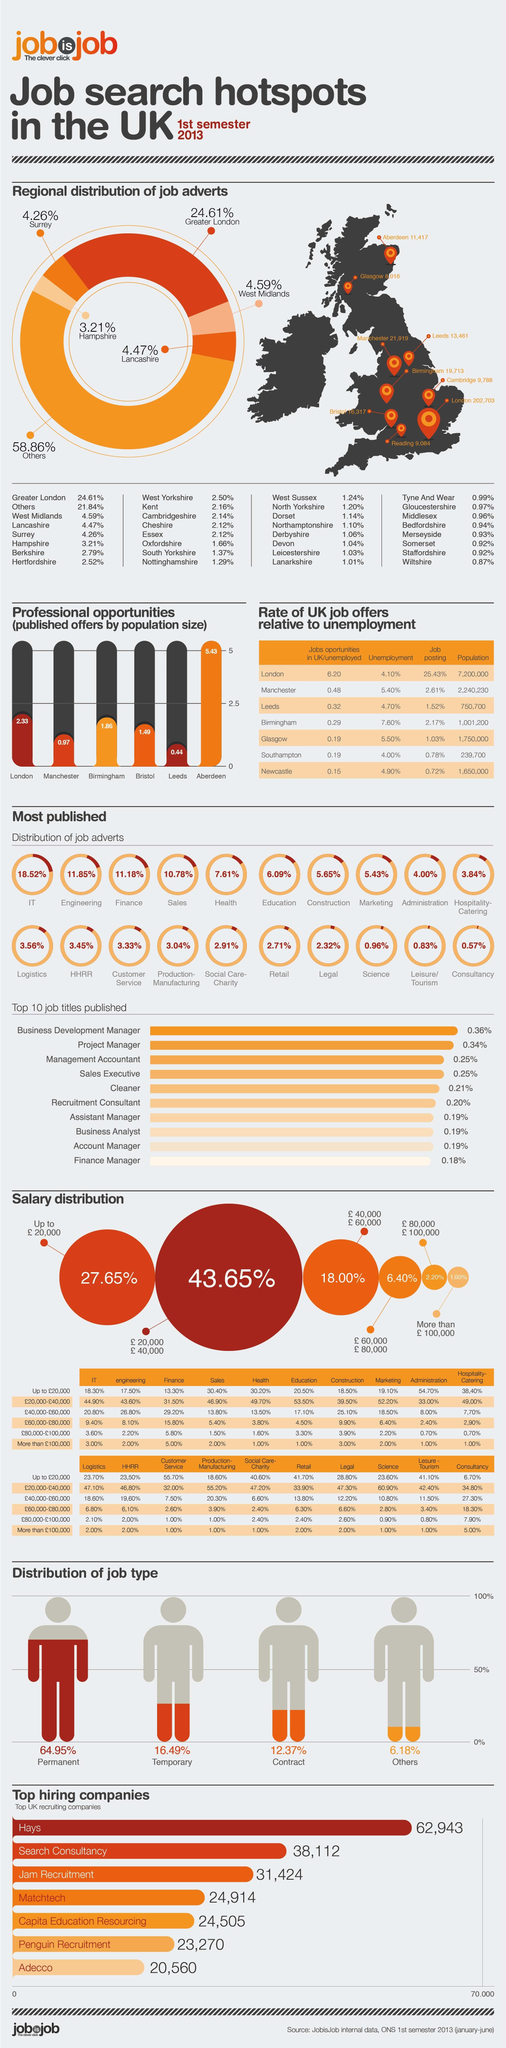What percentage of UK people has a permanent job type in 2013?
Answer the question with a short phrase. 64.95% Which city in UK has the highest population? London Which city in UK has the lowest unemployment rate in 2013? Southampton What percentage of UK people has a salary of more than £ 100,000 in 2013? 1.60% What percent of job adverts are published by the sales sector in UK in 2013? 10.78% Which city in UK has the highest unemployment rate in 2013? Birmingham What percent of job adverts are published by the education sector in UK in 2013? 6.09% What percentage of UK people has a contract job type in 2013? 12.37% What percentage of UK people has a salary range of  £20,000-£40,000 in 2013? 43.65% What is the unemployment rate in Manchester city in 2013? 5.40% 